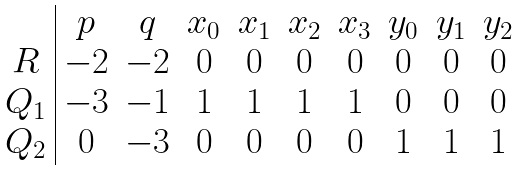Convert formula to latex. <formula><loc_0><loc_0><loc_500><loc_500>\begin{array} { c | c c c c c c c c c } & p & q & x _ { 0 } & x _ { 1 } & x _ { 2 } & x _ { 3 } & y _ { 0 } & y _ { 1 } & y _ { 2 } \\ R & - 2 & - 2 & 0 & 0 & 0 & 0 & 0 & 0 & 0 \\ Q _ { 1 } & - 3 & - 1 & 1 & 1 & 1 & 1 & 0 & 0 & 0 \\ Q _ { 2 } & 0 & - 3 & 0 & 0 & 0 & 0 & 1 & 1 & 1 \end{array}</formula> 